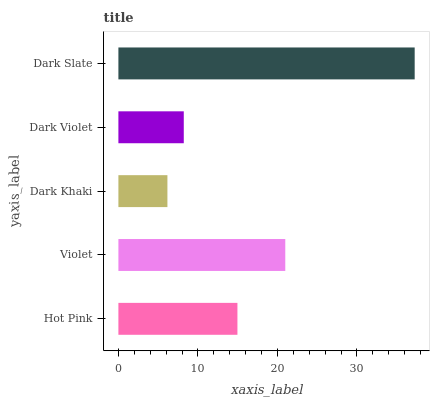Is Dark Khaki the minimum?
Answer yes or no. Yes. Is Dark Slate the maximum?
Answer yes or no. Yes. Is Violet the minimum?
Answer yes or no. No. Is Violet the maximum?
Answer yes or no. No. Is Violet greater than Hot Pink?
Answer yes or no. Yes. Is Hot Pink less than Violet?
Answer yes or no. Yes. Is Hot Pink greater than Violet?
Answer yes or no. No. Is Violet less than Hot Pink?
Answer yes or no. No. Is Hot Pink the high median?
Answer yes or no. Yes. Is Hot Pink the low median?
Answer yes or no. Yes. Is Violet the high median?
Answer yes or no. No. Is Dark Violet the low median?
Answer yes or no. No. 